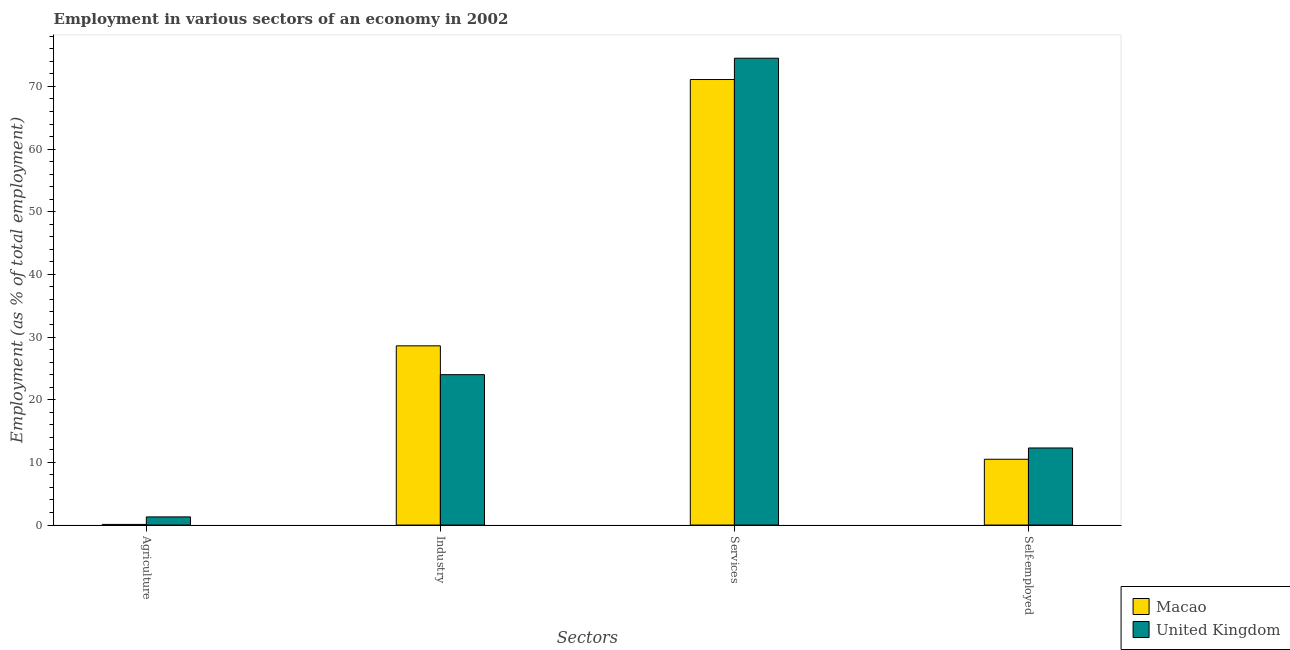How many different coloured bars are there?
Offer a very short reply. 2. How many groups of bars are there?
Ensure brevity in your answer.  4. What is the label of the 4th group of bars from the left?
Provide a short and direct response. Self-employed. What is the percentage of workers in services in United Kingdom?
Give a very brief answer. 74.5. Across all countries, what is the maximum percentage of workers in agriculture?
Offer a terse response. 1.3. Across all countries, what is the minimum percentage of workers in services?
Give a very brief answer. 71.1. In which country was the percentage of self employed workers maximum?
Your response must be concise. United Kingdom. In which country was the percentage of workers in industry minimum?
Make the answer very short. United Kingdom. What is the total percentage of workers in agriculture in the graph?
Your answer should be very brief. 1.4. What is the difference between the percentage of workers in services in United Kingdom and that in Macao?
Provide a succinct answer. 3.4. What is the difference between the percentage of workers in services in Macao and the percentage of workers in industry in United Kingdom?
Offer a very short reply. 47.1. What is the average percentage of workers in services per country?
Your answer should be very brief. 72.8. What is the difference between the percentage of workers in agriculture and percentage of workers in industry in United Kingdom?
Offer a very short reply. -22.7. In how many countries, is the percentage of self employed workers greater than 76 %?
Your response must be concise. 0. What is the ratio of the percentage of workers in services in United Kingdom to that in Macao?
Your answer should be very brief. 1.05. What is the difference between the highest and the second highest percentage of workers in industry?
Offer a terse response. 4.6. What is the difference between the highest and the lowest percentage of workers in industry?
Provide a short and direct response. 4.6. Is the sum of the percentage of self employed workers in United Kingdom and Macao greater than the maximum percentage of workers in agriculture across all countries?
Your answer should be very brief. Yes. What does the 2nd bar from the left in Agriculture represents?
Provide a succinct answer. United Kingdom. Is it the case that in every country, the sum of the percentage of workers in agriculture and percentage of workers in industry is greater than the percentage of workers in services?
Provide a succinct answer. No. How many bars are there?
Ensure brevity in your answer.  8. How many countries are there in the graph?
Offer a very short reply. 2. Does the graph contain any zero values?
Ensure brevity in your answer.  No. Does the graph contain grids?
Offer a very short reply. No. Where does the legend appear in the graph?
Offer a very short reply. Bottom right. What is the title of the graph?
Provide a short and direct response. Employment in various sectors of an economy in 2002. What is the label or title of the X-axis?
Give a very brief answer. Sectors. What is the label or title of the Y-axis?
Ensure brevity in your answer.  Employment (as % of total employment). What is the Employment (as % of total employment) of Macao in Agriculture?
Your response must be concise. 0.1. What is the Employment (as % of total employment) of United Kingdom in Agriculture?
Offer a very short reply. 1.3. What is the Employment (as % of total employment) of Macao in Industry?
Provide a short and direct response. 28.6. What is the Employment (as % of total employment) in Macao in Services?
Ensure brevity in your answer.  71.1. What is the Employment (as % of total employment) in United Kingdom in Services?
Make the answer very short. 74.5. What is the Employment (as % of total employment) of United Kingdom in Self-employed?
Give a very brief answer. 12.3. Across all Sectors, what is the maximum Employment (as % of total employment) of Macao?
Keep it short and to the point. 71.1. Across all Sectors, what is the maximum Employment (as % of total employment) of United Kingdom?
Ensure brevity in your answer.  74.5. Across all Sectors, what is the minimum Employment (as % of total employment) in Macao?
Keep it short and to the point. 0.1. Across all Sectors, what is the minimum Employment (as % of total employment) in United Kingdom?
Provide a succinct answer. 1.3. What is the total Employment (as % of total employment) of Macao in the graph?
Offer a terse response. 110.3. What is the total Employment (as % of total employment) in United Kingdom in the graph?
Your answer should be very brief. 112.1. What is the difference between the Employment (as % of total employment) of Macao in Agriculture and that in Industry?
Your answer should be very brief. -28.5. What is the difference between the Employment (as % of total employment) in United Kingdom in Agriculture and that in Industry?
Ensure brevity in your answer.  -22.7. What is the difference between the Employment (as % of total employment) of Macao in Agriculture and that in Services?
Provide a short and direct response. -71. What is the difference between the Employment (as % of total employment) in United Kingdom in Agriculture and that in Services?
Provide a succinct answer. -73.2. What is the difference between the Employment (as % of total employment) in United Kingdom in Agriculture and that in Self-employed?
Ensure brevity in your answer.  -11. What is the difference between the Employment (as % of total employment) of Macao in Industry and that in Services?
Your answer should be compact. -42.5. What is the difference between the Employment (as % of total employment) in United Kingdom in Industry and that in Services?
Provide a short and direct response. -50.5. What is the difference between the Employment (as % of total employment) of United Kingdom in Industry and that in Self-employed?
Your answer should be compact. 11.7. What is the difference between the Employment (as % of total employment) in Macao in Services and that in Self-employed?
Keep it short and to the point. 60.6. What is the difference between the Employment (as % of total employment) of United Kingdom in Services and that in Self-employed?
Keep it short and to the point. 62.2. What is the difference between the Employment (as % of total employment) in Macao in Agriculture and the Employment (as % of total employment) in United Kingdom in Industry?
Make the answer very short. -23.9. What is the difference between the Employment (as % of total employment) in Macao in Agriculture and the Employment (as % of total employment) in United Kingdom in Services?
Your response must be concise. -74.4. What is the difference between the Employment (as % of total employment) in Macao in Industry and the Employment (as % of total employment) in United Kingdom in Services?
Your answer should be compact. -45.9. What is the difference between the Employment (as % of total employment) in Macao in Industry and the Employment (as % of total employment) in United Kingdom in Self-employed?
Give a very brief answer. 16.3. What is the difference between the Employment (as % of total employment) of Macao in Services and the Employment (as % of total employment) of United Kingdom in Self-employed?
Give a very brief answer. 58.8. What is the average Employment (as % of total employment) of Macao per Sectors?
Offer a very short reply. 27.57. What is the average Employment (as % of total employment) in United Kingdom per Sectors?
Provide a succinct answer. 28.02. What is the difference between the Employment (as % of total employment) in Macao and Employment (as % of total employment) in United Kingdom in Industry?
Your response must be concise. 4.6. What is the ratio of the Employment (as % of total employment) of Macao in Agriculture to that in Industry?
Make the answer very short. 0. What is the ratio of the Employment (as % of total employment) of United Kingdom in Agriculture to that in Industry?
Your response must be concise. 0.05. What is the ratio of the Employment (as % of total employment) of Macao in Agriculture to that in Services?
Give a very brief answer. 0. What is the ratio of the Employment (as % of total employment) in United Kingdom in Agriculture to that in Services?
Provide a short and direct response. 0.02. What is the ratio of the Employment (as % of total employment) of Macao in Agriculture to that in Self-employed?
Keep it short and to the point. 0.01. What is the ratio of the Employment (as % of total employment) in United Kingdom in Agriculture to that in Self-employed?
Your answer should be compact. 0.11. What is the ratio of the Employment (as % of total employment) of Macao in Industry to that in Services?
Provide a succinct answer. 0.4. What is the ratio of the Employment (as % of total employment) of United Kingdom in Industry to that in Services?
Make the answer very short. 0.32. What is the ratio of the Employment (as % of total employment) in Macao in Industry to that in Self-employed?
Ensure brevity in your answer.  2.72. What is the ratio of the Employment (as % of total employment) in United Kingdom in Industry to that in Self-employed?
Make the answer very short. 1.95. What is the ratio of the Employment (as % of total employment) in Macao in Services to that in Self-employed?
Provide a succinct answer. 6.77. What is the ratio of the Employment (as % of total employment) in United Kingdom in Services to that in Self-employed?
Your answer should be very brief. 6.06. What is the difference between the highest and the second highest Employment (as % of total employment) in Macao?
Your response must be concise. 42.5. What is the difference between the highest and the second highest Employment (as % of total employment) of United Kingdom?
Your answer should be compact. 50.5. What is the difference between the highest and the lowest Employment (as % of total employment) of United Kingdom?
Your answer should be compact. 73.2. 